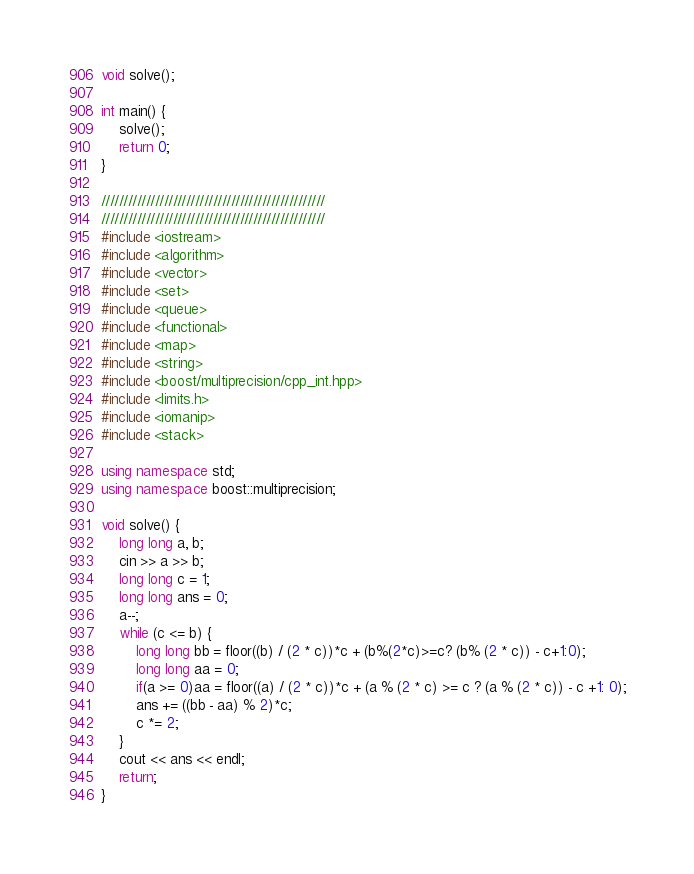<code> <loc_0><loc_0><loc_500><loc_500><_C++_>void solve();

int main() {
	solve();
	return 0;
}

//////////////////////////////////////////////////
//////////////////////////////////////////////////
#include <iostream>
#include <algorithm>
#include <vector>
#include <set>
#include <queue>
#include <functional>
#include <map>
#include <string>
#include <boost/multiprecision/cpp_int.hpp>
#include <limits.h>
#include <iomanip>
#include <stack>

using namespace std;
using namespace boost::multiprecision;

void solve() {
	long long a, b;
	cin >> a >> b;
	long long c = 1;
	long long ans = 0;
	a--;
	while (c <= b) {
		long long bb = floor((b) / (2 * c))*c + (b%(2*c)>=c? (b% (2 * c)) - c+1:0);
		long long aa = 0;
		if(a >= 0)aa = floor((a) / (2 * c))*c + (a % (2 * c) >= c ? (a % (2 * c)) - c +1: 0);
		ans += ((bb - aa) % 2)*c;
		c *= 2;
	}
	cout << ans << endl;
	return;
}</code> 